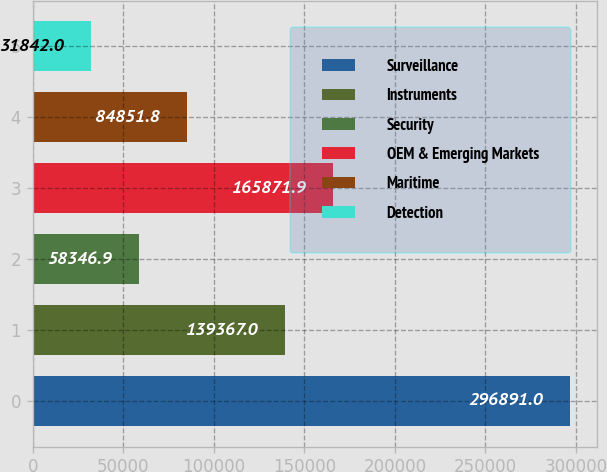Convert chart. <chart><loc_0><loc_0><loc_500><loc_500><bar_chart><fcel>Surveillance<fcel>Instruments<fcel>Security<fcel>OEM & Emerging Markets<fcel>Maritime<fcel>Detection<nl><fcel>296891<fcel>139367<fcel>58346.9<fcel>165872<fcel>84851.8<fcel>31842<nl></chart> 